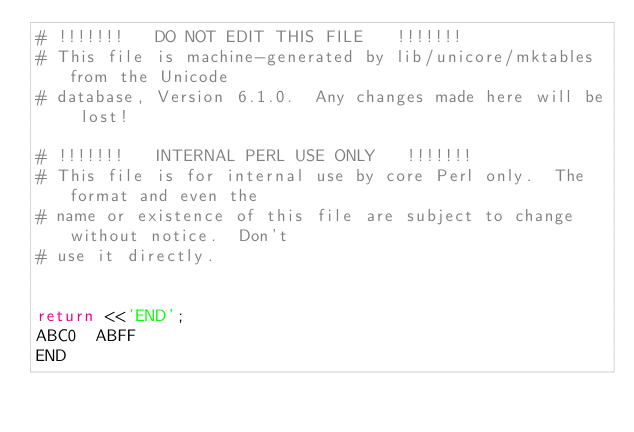Convert code to text. <code><loc_0><loc_0><loc_500><loc_500><_Perl_># !!!!!!!   DO NOT EDIT THIS FILE   !!!!!!!
# This file is machine-generated by lib/unicore/mktables from the Unicode
# database, Version 6.1.0.  Any changes made here will be lost!

# !!!!!!!   INTERNAL PERL USE ONLY   !!!!!!!
# This file is for internal use by core Perl only.  The format and even the
# name or existence of this file are subject to change without notice.  Don't
# use it directly.


return <<'END';
ABC0	ABFF
END
</code> 